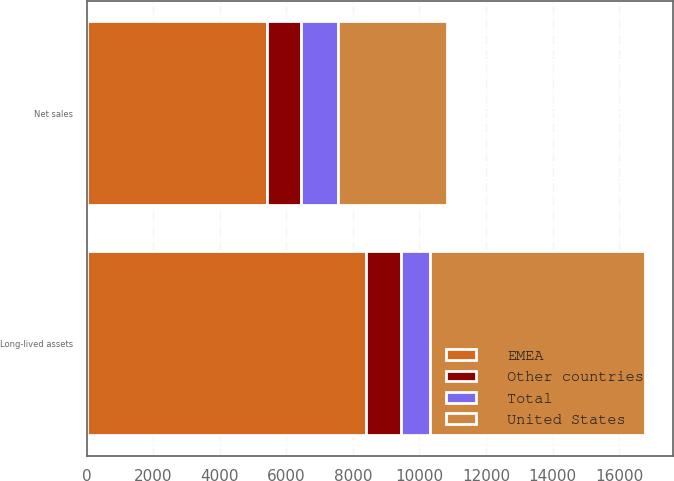Convert chart. <chart><loc_0><loc_0><loc_500><loc_500><stacked_bar_chart><ecel><fcel>Net sales<fcel>Long-lived assets<nl><fcel>United States<fcel>3266.9<fcel>6449.7<nl><fcel>Other countries<fcel>1021.1<fcel>1060<nl><fcel>Total<fcel>1120.9<fcel>876.6<nl><fcel>EMEA<fcel>5408.9<fcel>8386.3<nl></chart> 